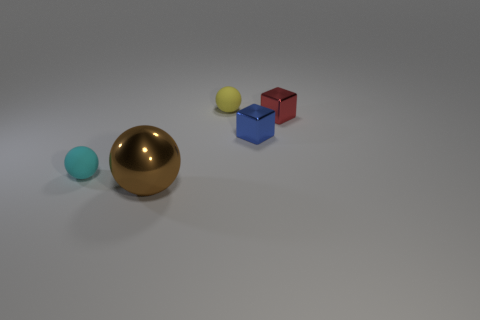Are there the same number of blue metallic objects that are on the left side of the blue shiny thing and metallic objects? The image shows a total of two metallic objects, one of which is blue and the other appears to be gold or brass. The blue metallic object is positioned on the left side of a large shiny blue sphere. Therefore, the answer is yes, there is an equal number of blue metallic objects and metallic objects to the left of the blue shiny sphere, which is one. 